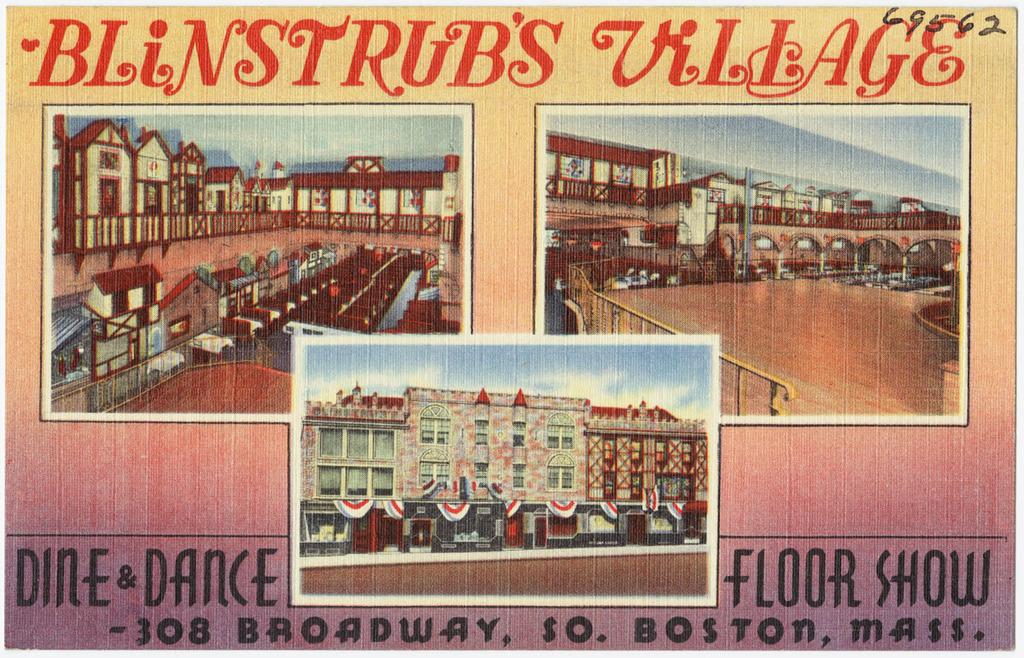Where is this ad?
Make the answer very short. Boston, mass. What is being advertised?
Ensure brevity in your answer.  Blinstrub's village. 